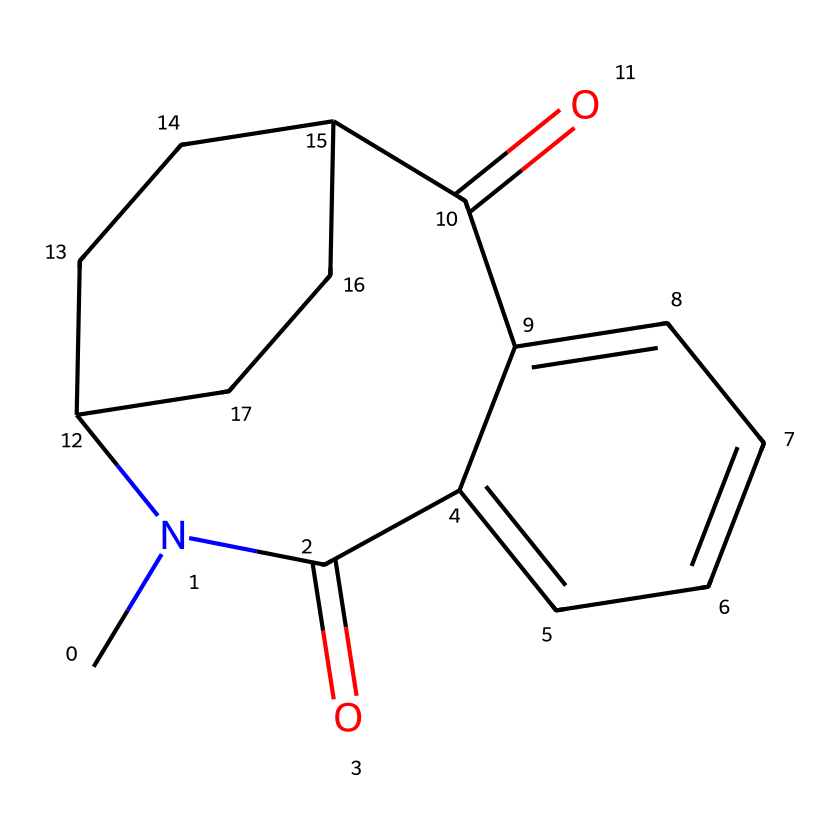how many rings are present in the structure? By examining the SMILES representation, we can identify the cyclic structures. The presence of 'C' and 'C' connected in a loop indicates the presence of rings. In this case, there are two distinct rings formed from the structure.
Answer: two what is the molecular formula of the compound? The molecular formula can be derived from counting the total number of carbon (C), hydrogen (H), nitrogen (N), and oxygen (O) atoms in the structure. The SMILES indicates 13 carbon atoms, 15 hydrogen atoms, 1 nitrogen atom, and 2 oxygen atoms. Thus, the molecular formula is C13H15N1O2.
Answer: C13H15NO2 which functional group is present in this drug? The drug contains an amide functional group, which is characterized by the 'C(=O)N' pattern seen in the structure. The presence of a carbonyl group (C=O) connected to a nitrogen atom (N) identifies it as an amide.
Answer: amide how do the enantiomers of Thalidomide compare in terms of their biological activity? The enantiomers of Thalidomide exhibit differing biological activities; one enantiomer is therapeutic while the other is teratogenic. This difference in activity is akin to how different sorting algorithms can yield varied efficiencies based on their structures.
Answer: differing how many chiral centers does Thalidomide have? A chiral center is typically identified by a carbon atom that is bonded to four different substituents. By analyzing the SMILES representation, we can identify that Thalidomide has one chiral center in its structure.
Answer: one how would the therapeutic effects of Thalidomide relate to the stability of its enantiomers? The stability of enantiomers can affect their behavior in biological systems. Similar to how stable sorting algorithms consistently yield correct orderings, the more stable enantiomer of Thalidomide possesses the desired therapeutic effect, while the other does not.
Answer: stability impacts efficacy what type of drug is Thalidomide categorized as? Thalidomide is categorized as a sedative and anti-inflammatory drug, known for its immunomodulatory properties. This categorization is useful in understanding its mechanism of action, similar to how sorting algorithms are categorized by their complexity and use cases.
Answer: sedative 